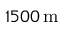<formula> <loc_0><loc_0><loc_500><loc_500>1 5 0 0 \, m</formula> 